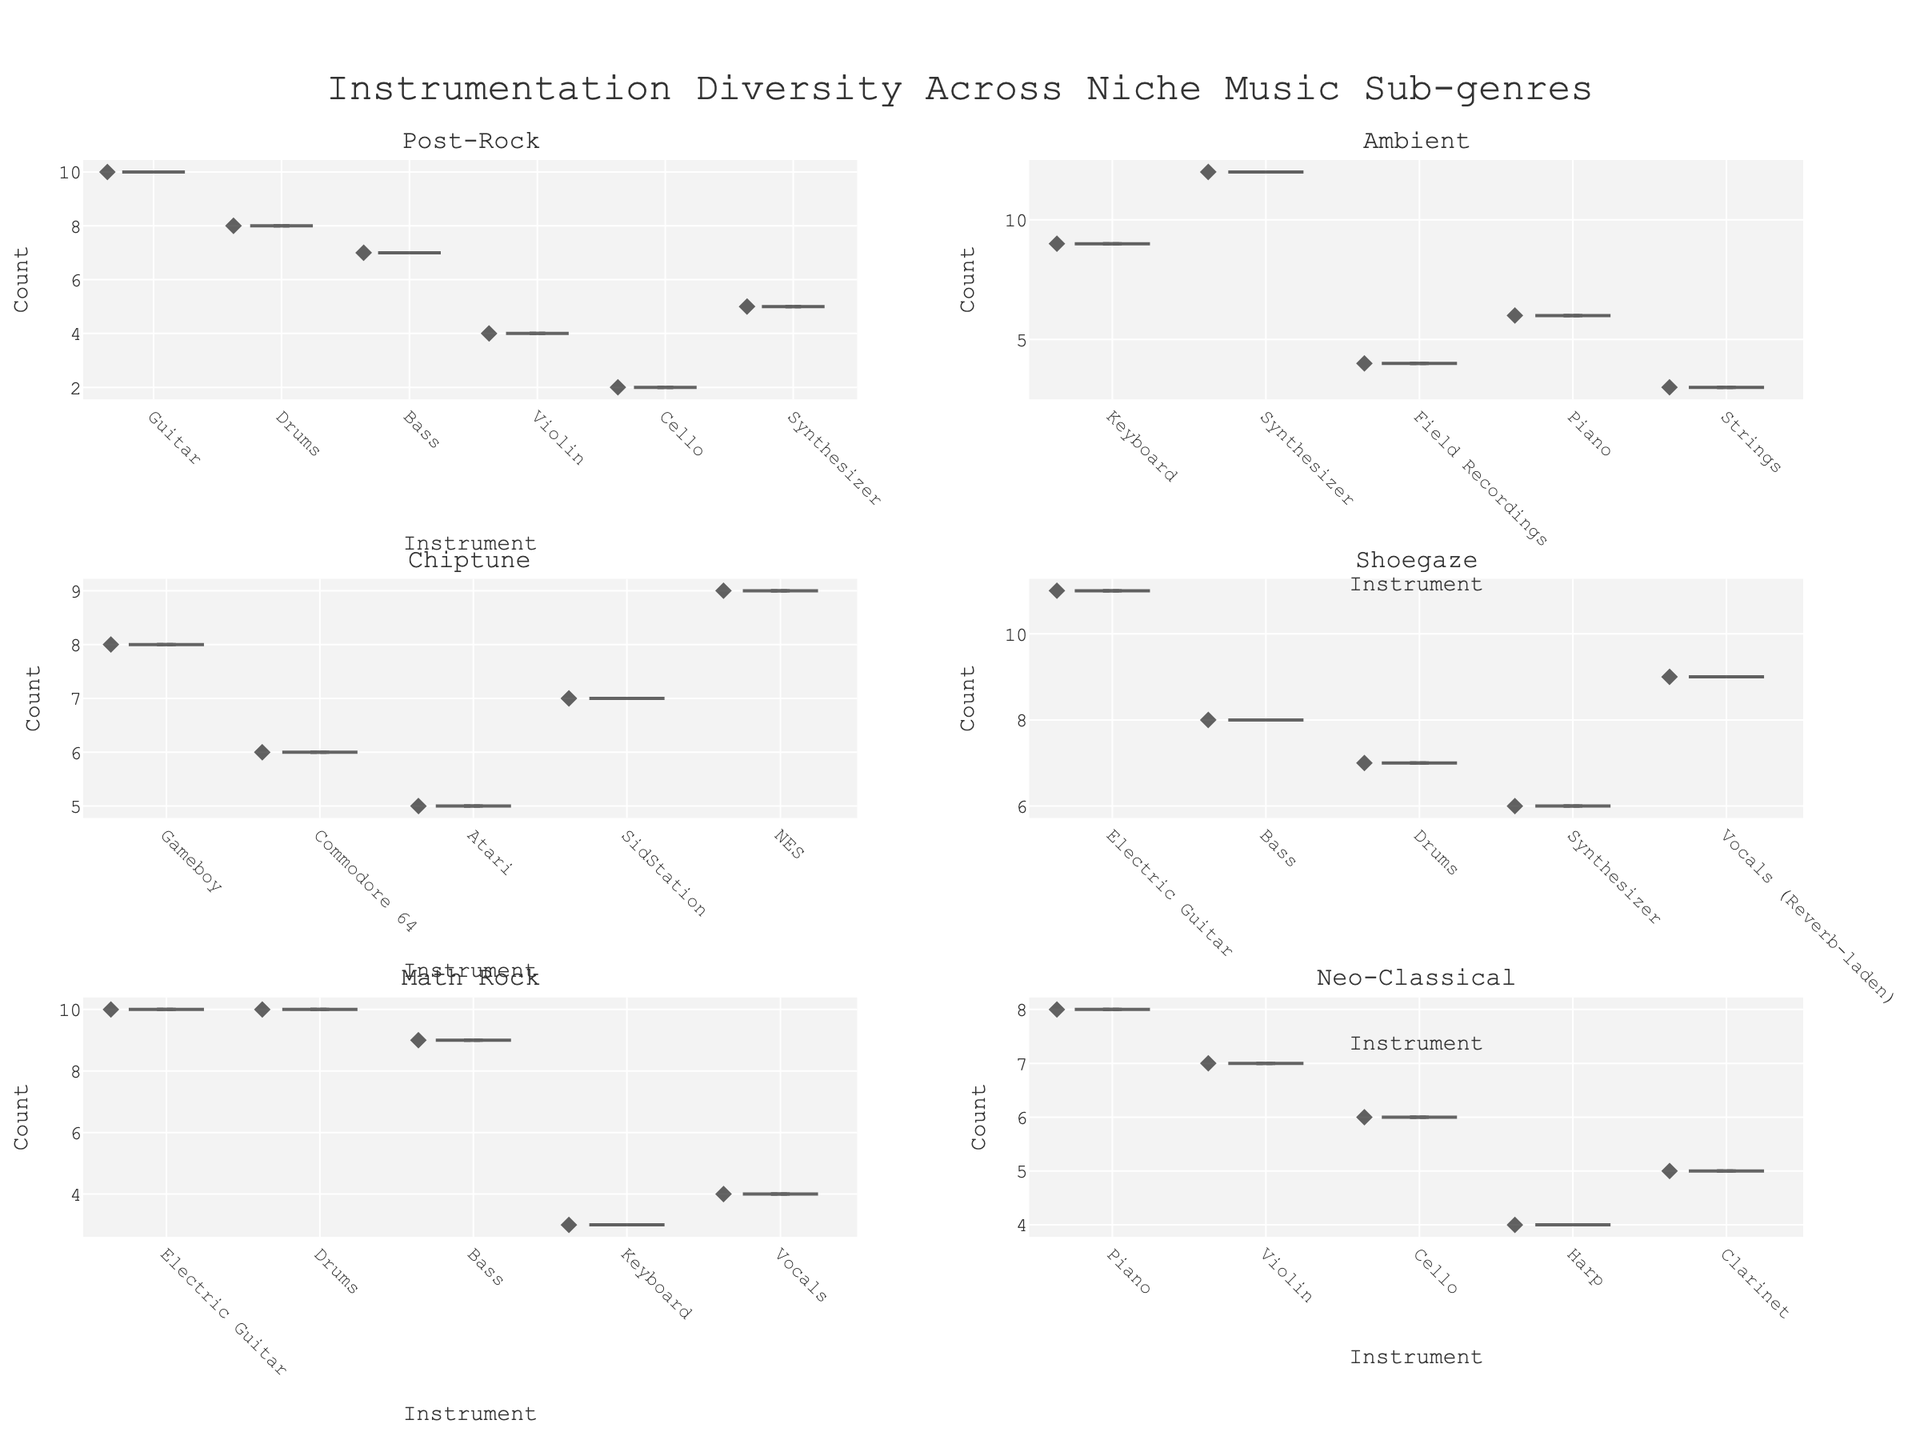What is the title of the figure? The title of the figure is clearly mentioned at the top, which is "Instrumentation Diversity Across Niche Music Sub-genres".
Answer: Instrumentation Diversity Across Niche Music Sub-genres How many sub-genres are covered in the figure? Each subplot corresponds to a unique sub-genre, and there are six titles for the subplots.
Answer: Six sub-genres Which sub-genre has the highest count for an instrument and what is the instrument? Shoegaze has the highest count for an instrument, which is the electric guitar with a count of 11. You can see this from the maximum point in the Shoegaze subplot.
Answer: Shoegaze, electric guitar In the Post-Rock sub-genre, what is the median count of instruments used? In the Post-Rock sub-genre, the counts are [2, 4, 5, 7, 8, 10]. The median is the average of the middle two values, which is (5 + 7) / 2 = 6.
Answer: 6 Which sub-genre shows the greatest diversity in instrumentation? Math Rock, as indicated by the spread of counts being less uniform compared to others, showing multiple instruments with high usage counts.
Answer: Math Rock How many unique instruments are used in the Ambient sub-genre? By counting the distinct entries on the x-axis for the Ambient subplot, we can see there are 5 unique instruments: Keyboard, Synthesizer, Field Recordings, Piano, and Strings.
Answer: 5 instruments Between Post-Rock and Chiptune, which sub-genre has a higher minimum count for any instrument, and what is that count? Comparing the minimum counts from both sub-genres, Post-Rock has a minimum count of 2, while Chiptune has a minimum count of 5. This makes Chiptune's minimum count higher.
Answer: Chiptune, 5 What is the average count of instruments in the Neo-Classical sub-genre? For Neo-Classical, the counts are [4, 5, 6, 7, 8]. The sum is 4 + 5 + 6 + 7 + 8 = 30. The average is 30 / 5 = 6.
Answer: 6 How does the instrumentation count for the Synthesizer in Ambient compare to that in Post-Rock? The count for the Synthesizer in Ambient is 12, while in Post-Rock, it is 5. Therefore, Ambient has a higher synthesizer count than Post-Rock.
Answer: Ambient has a higher count Which sub-genre has the same maximum count and for which instruments? Both Math Rock and Post-Rock have a maximum count of 10 for Electric Guitar in Math Rock and Guitar in Post-Rock.
Answer: Math Rock, Post-Rock 